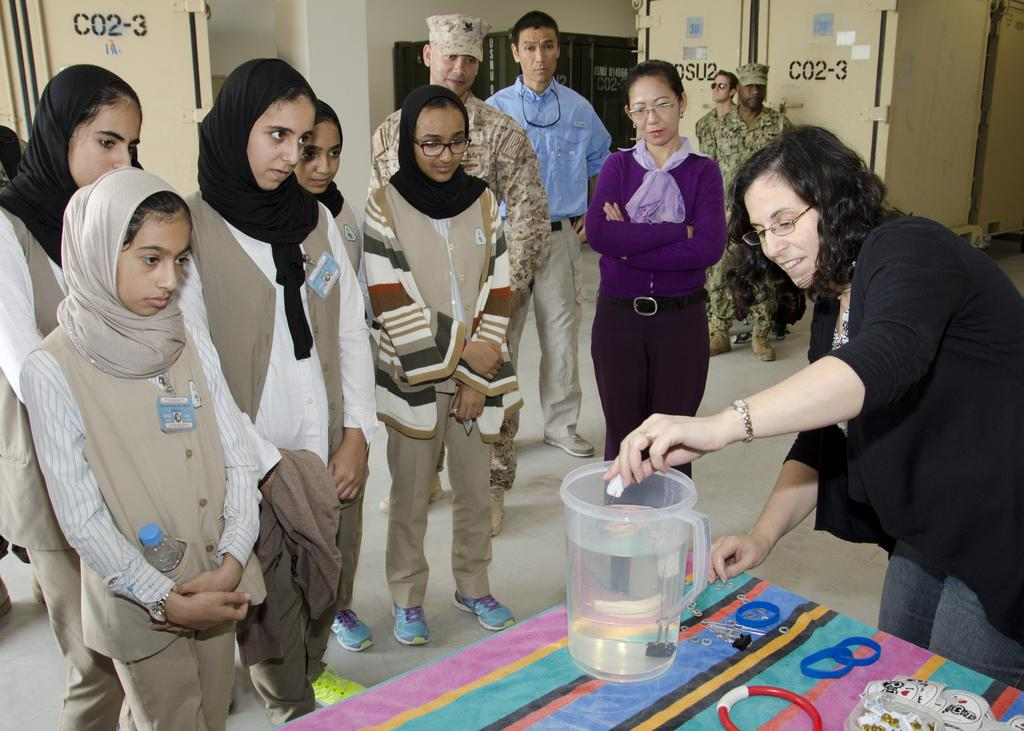Provide a one-sentence caption for the provided image. A group of people watch a science experiment at a military base with C02-3 Printed on multiple walls. 